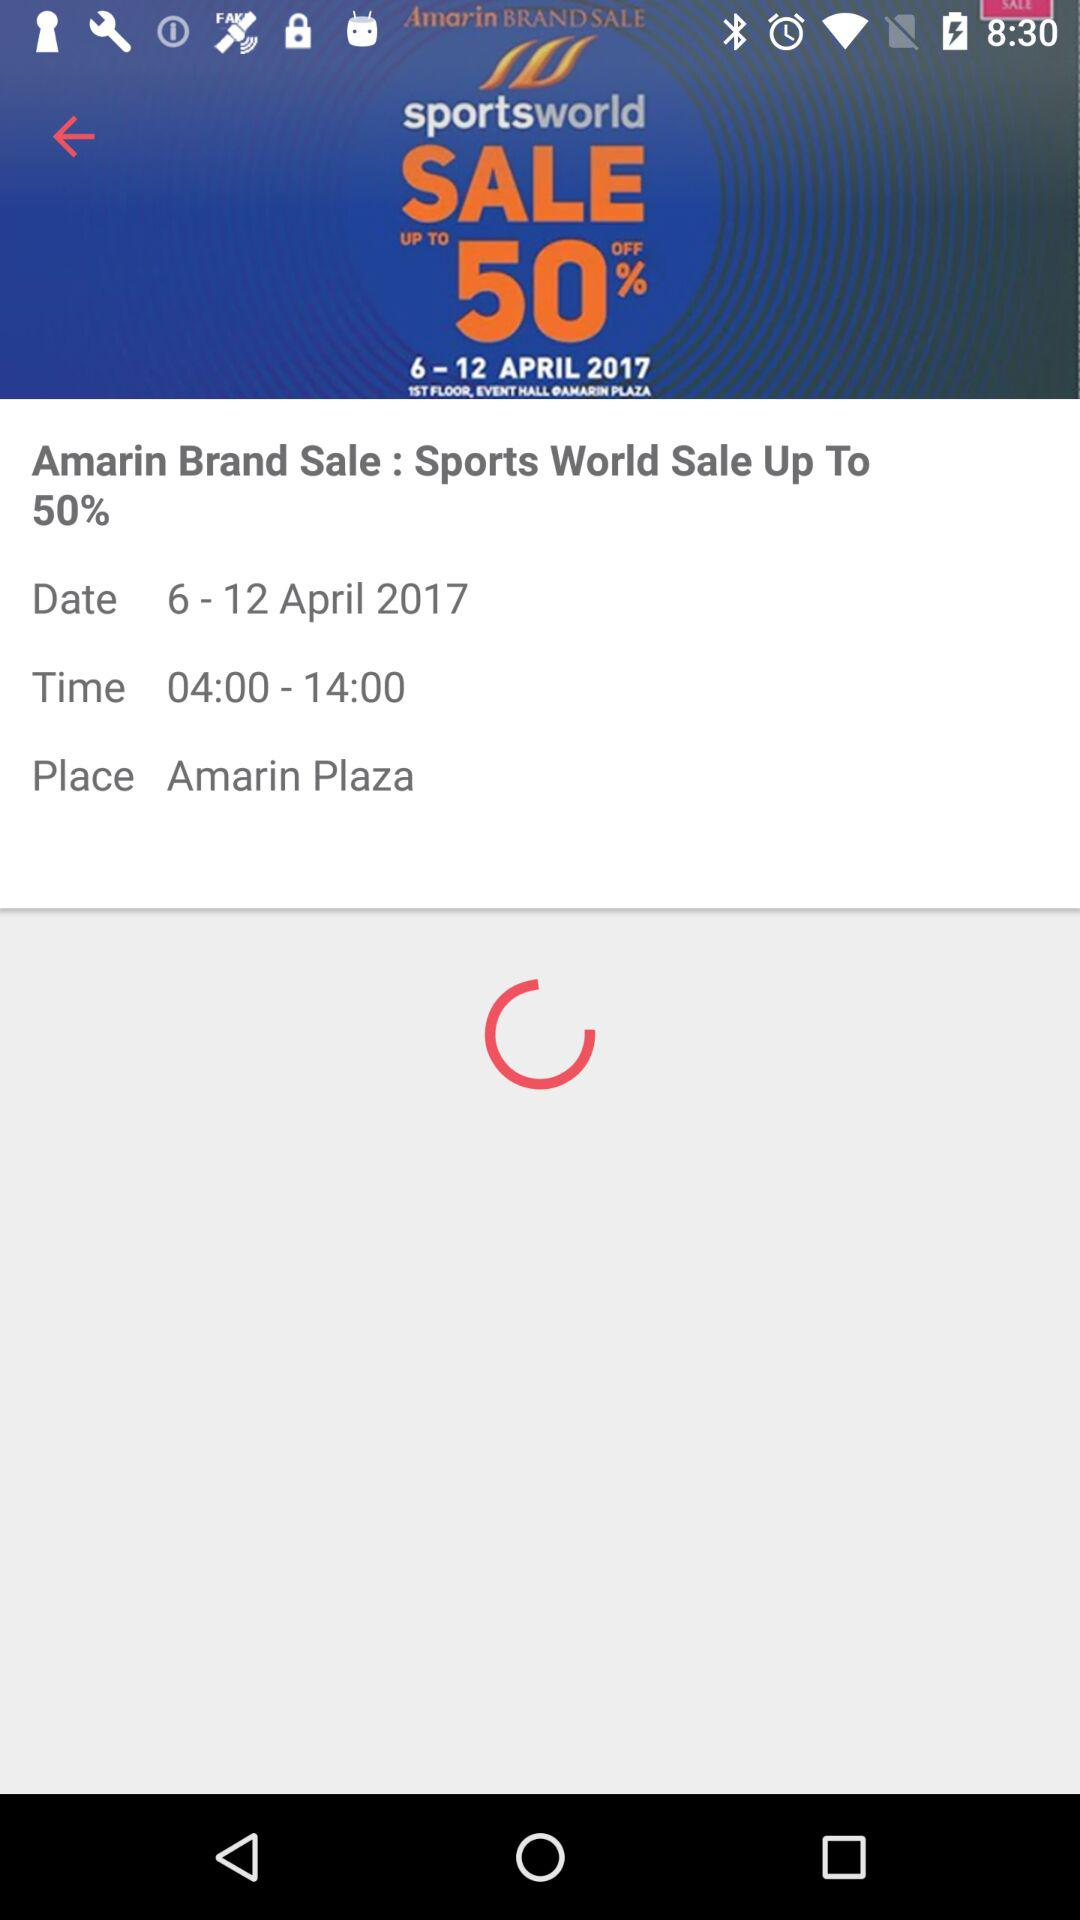What's the place? The place is Amarin Plaza. 